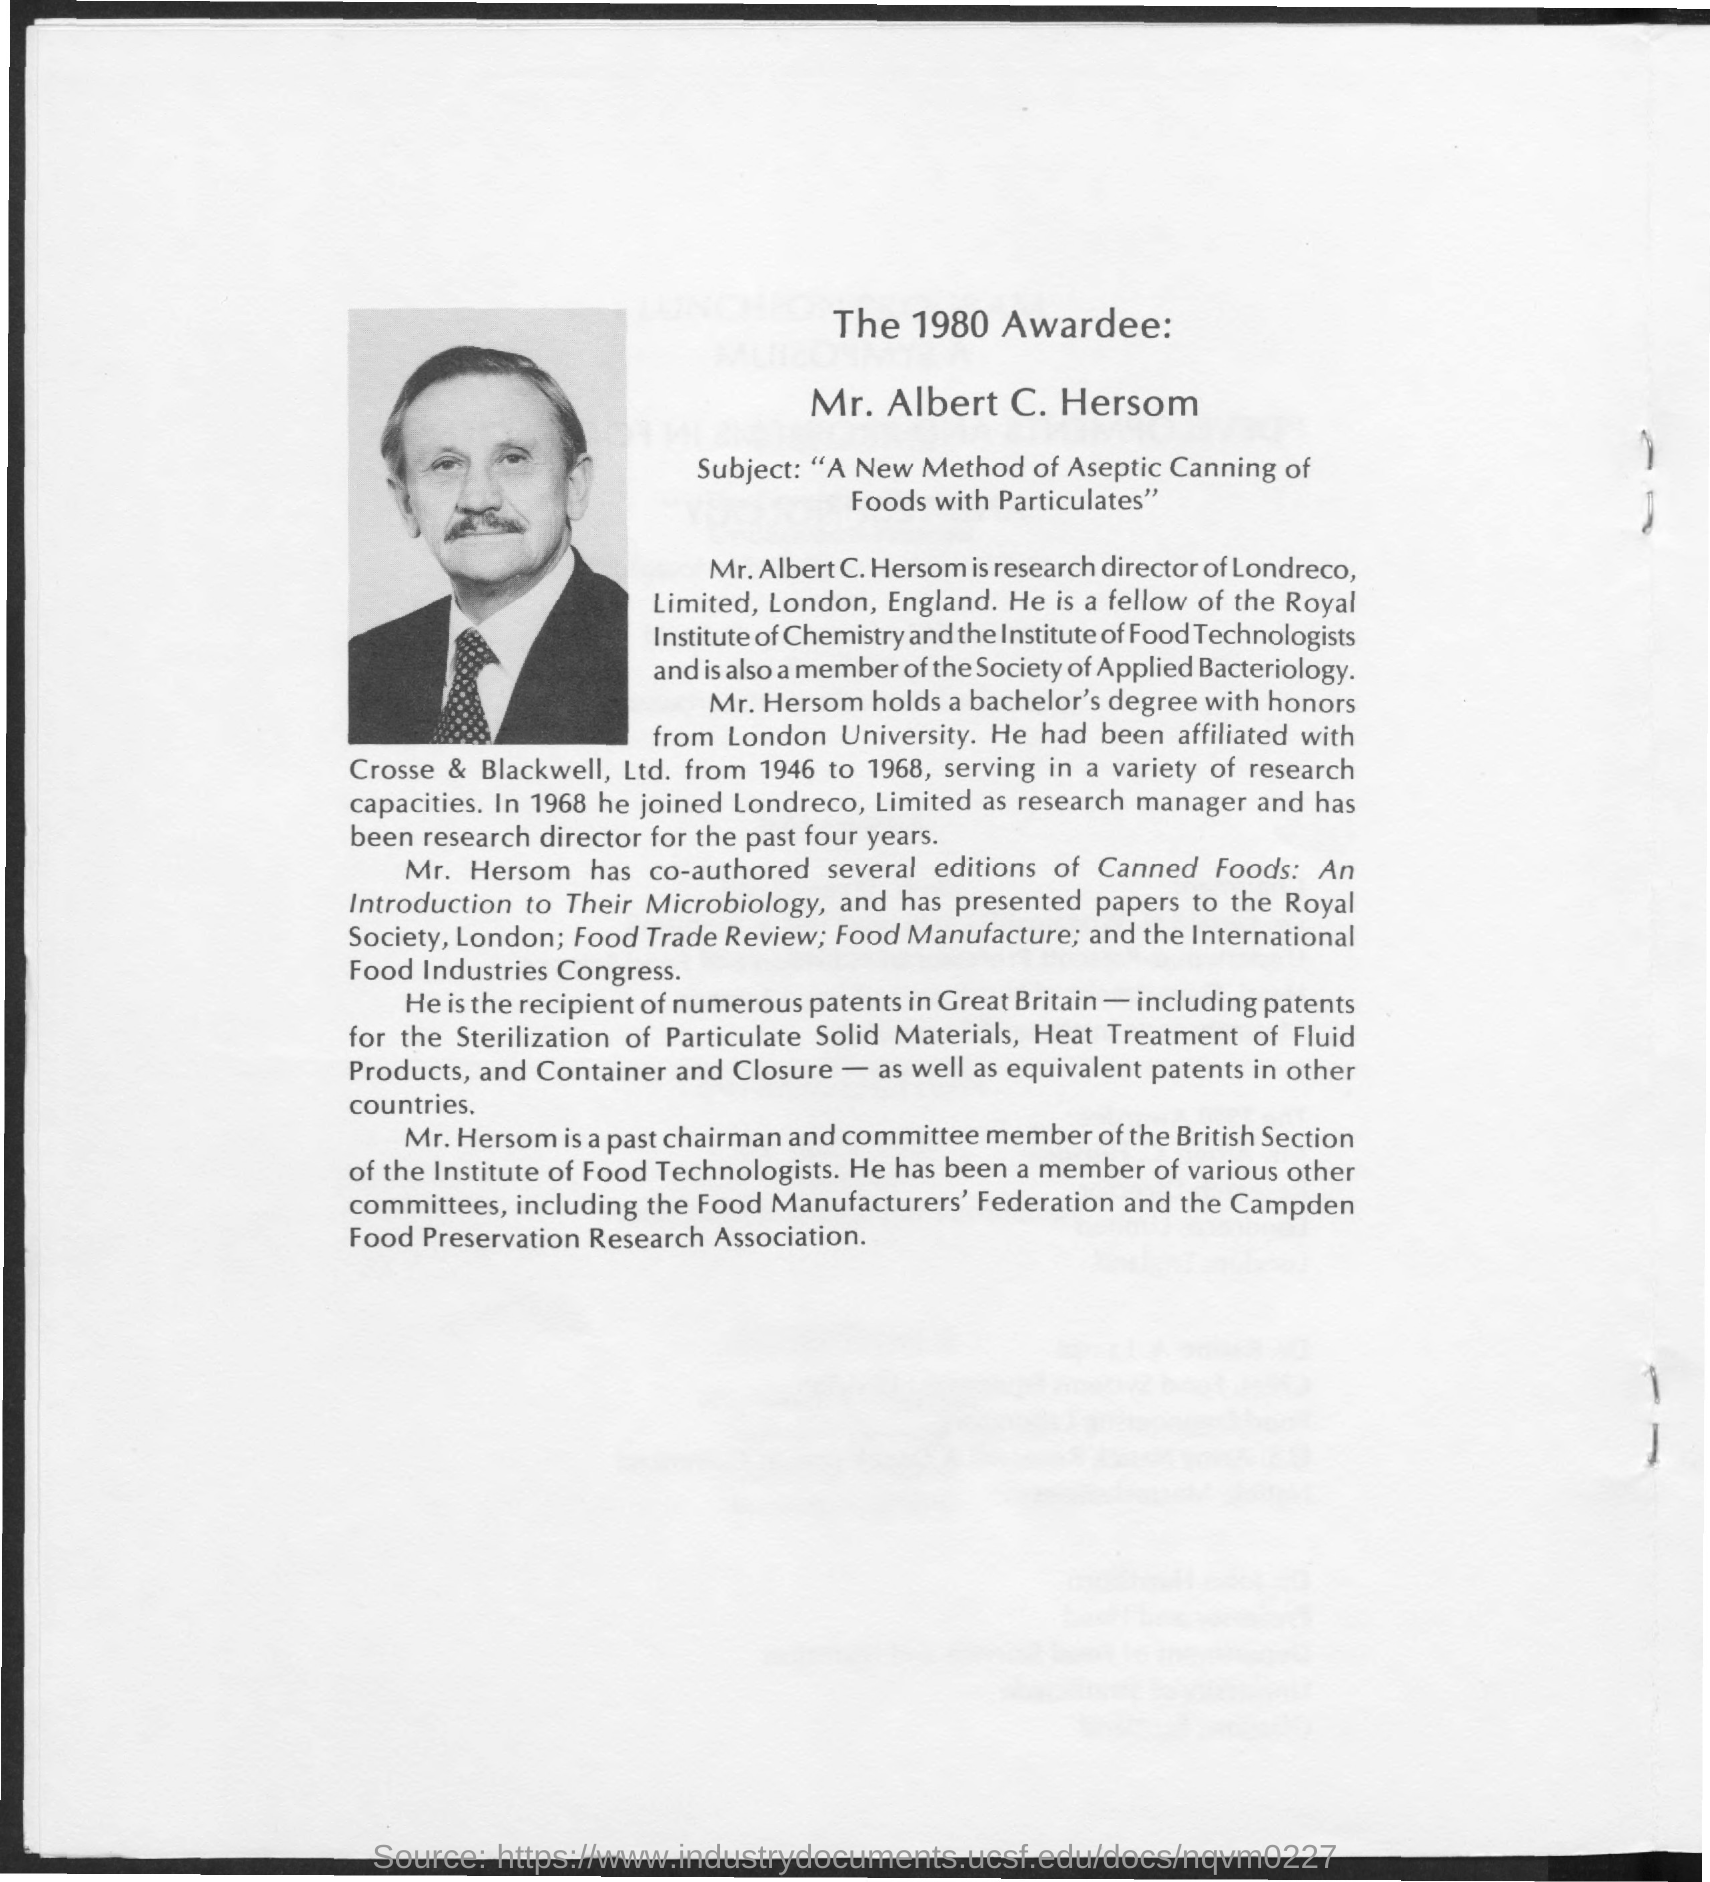Mr. Alber C. Hersom got the award in which year?
Provide a succinct answer. 1980. The Award is for which subject?
Offer a terse response. A New Method of Aseptic Canning of Foods with Particulates. 